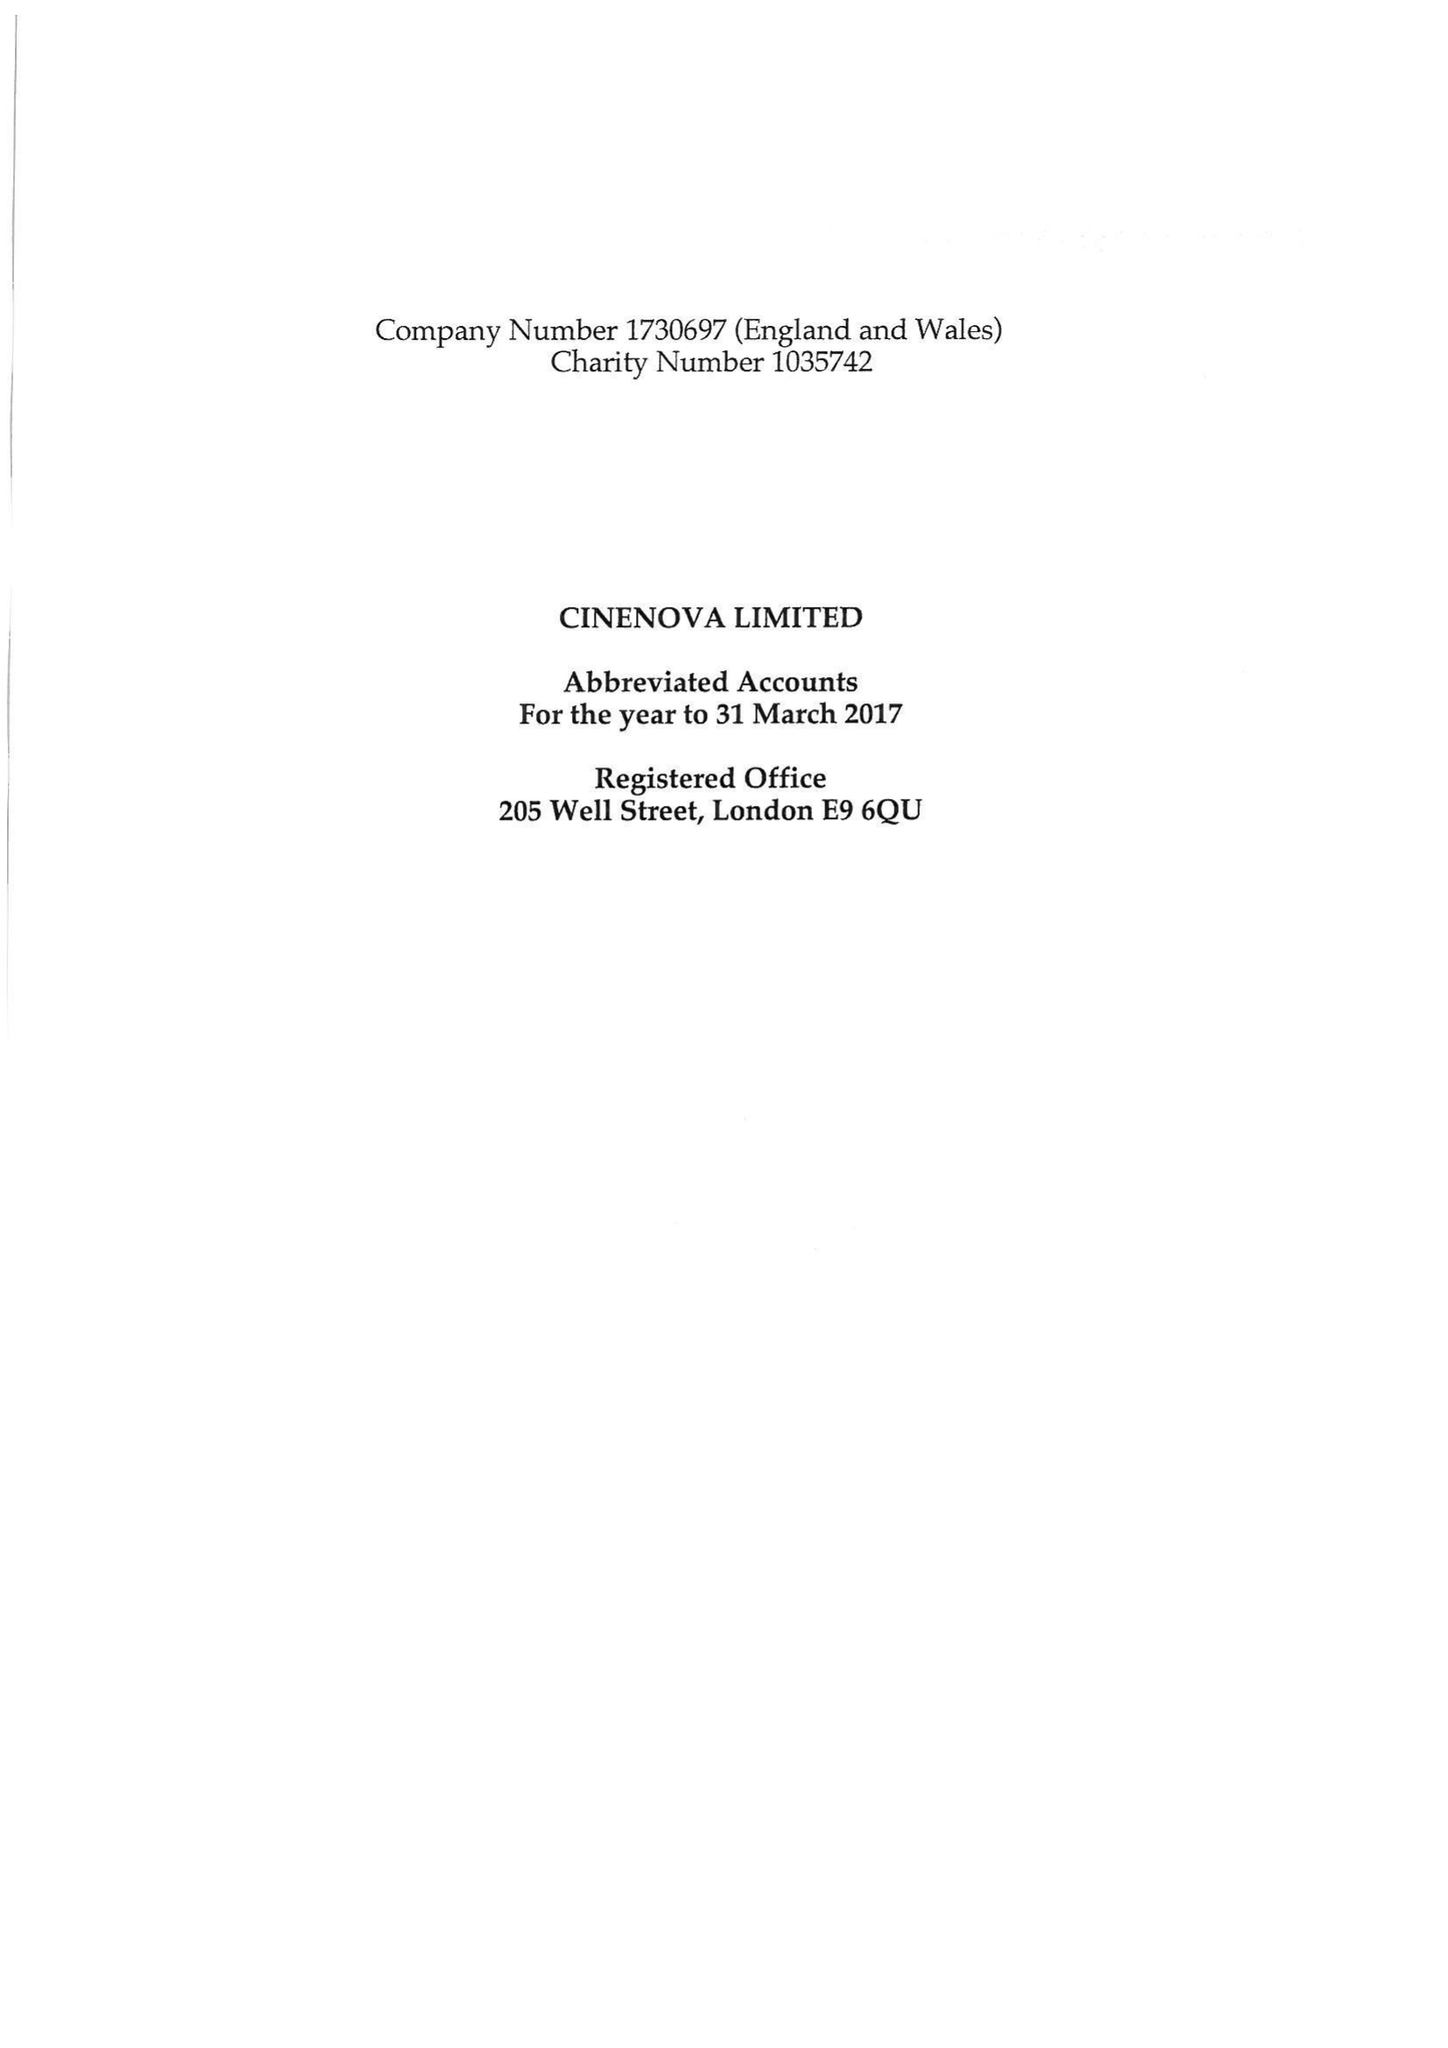What is the value for the spending_annually_in_british_pounds?
Answer the question using a single word or phrase. 97682.00 